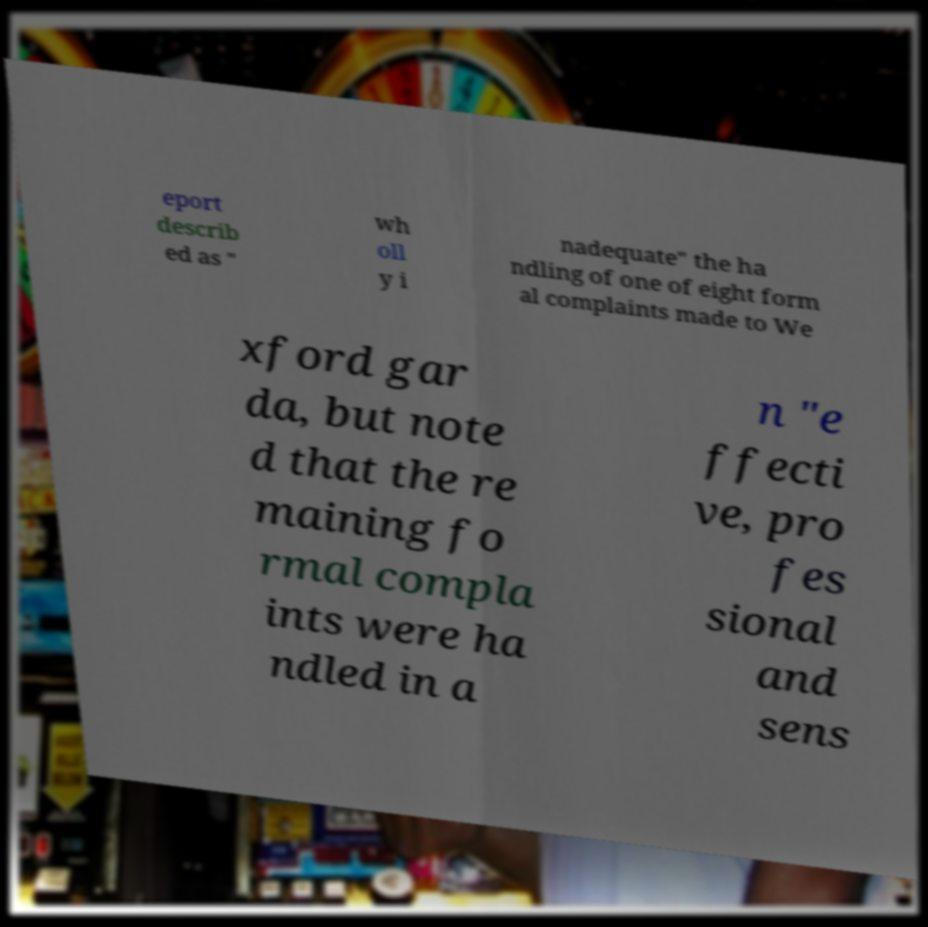There's text embedded in this image that I need extracted. Can you transcribe it verbatim? eport describ ed as " wh oll y i nadequate" the ha ndling of one of eight form al complaints made to We xford gar da, but note d that the re maining fo rmal compla ints were ha ndled in a n "e ffecti ve, pro fes sional and sens 